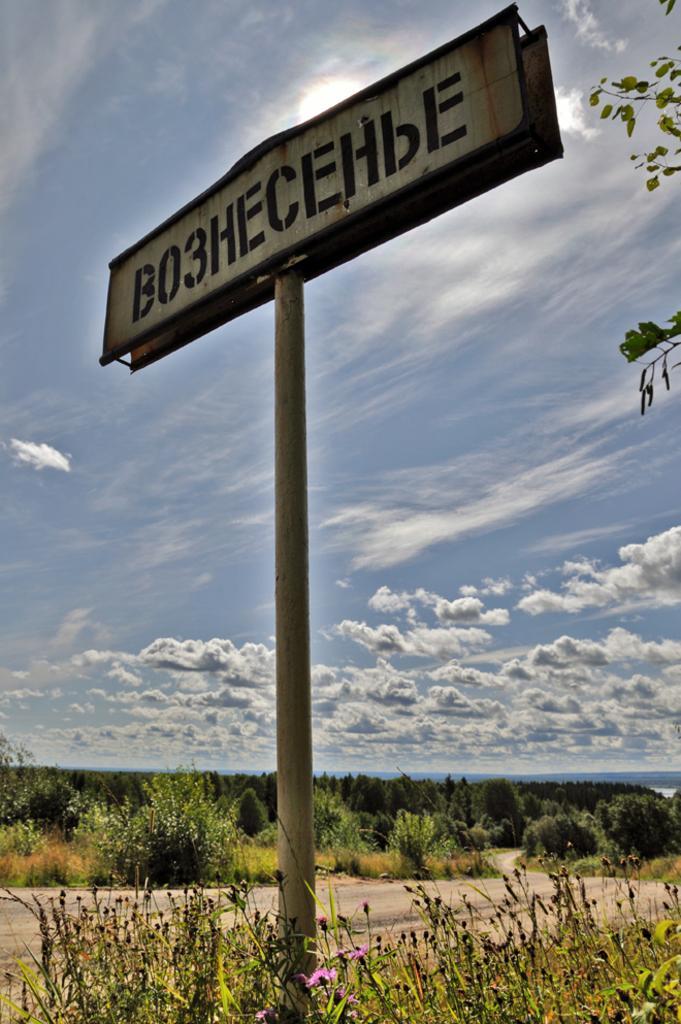Describe this image in one or two sentences. We can see board on pole and plants,right side of the image we can see leaves. In the background we can see grass,plants and sky with clouds. 